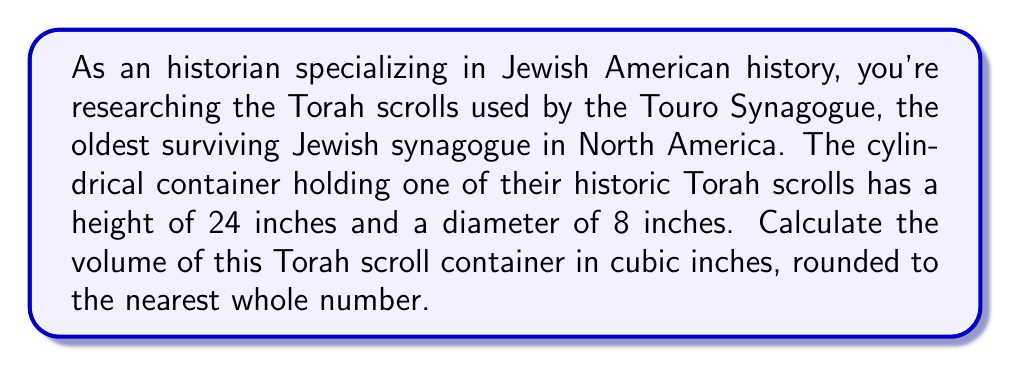Can you answer this question? To solve this problem, we need to use the formula for the volume of a cylinder:

$$V = \pi r^2 h$$

Where:
$V$ = volume
$\pi$ = pi (approximately 3.14159)
$r$ = radius of the base
$h$ = height of the cylinder

Given:
- Height (h) = 24 inches
- Diameter = 8 inches

Step 1: Calculate the radius
The radius is half the diameter:
$r = 8 \div 2 = 4$ inches

Step 2: Apply the volume formula
$$V = \pi (4\text{ in})^2 (24\text{ in})$$

Step 3: Simplify
$$V = \pi (16\text{ in}^2) (24\text{ in})$$
$$V = 384\pi\text{ in}^3$$

Step 4: Calculate and round to the nearest whole number
$$V \approx 384 \times 3.14159 \approx 1206.37\text{ in}^3$$

Rounded to the nearest whole number: 1206 cubic inches

[asy]
import three;

size(200);
currentprojection=perspective(6,3,2);

triple cyl_center = (0,0,12);
path3 p = circle((0,0,0),4);

draw(surface(p -- shift(0,0,24)*p -- cycle), paleblue+opacity(.5));
draw(p,blue);
draw(shift(0,0,24)*p,blue);

draw((4,0,0)--(4,0,24),blue+dashed);
draw((0,4,0)--(0,4,24),blue+dashed);
draw((-4,0,0)--(-4,0,24),blue+dashed);
draw((0,-4,0)--(0,-4,24),blue+dashed);

label("24 in", (5,0,12), E);
label("8 in", (0,0,-1), S);

dot(cyl_center,red);
[/asy]
Answer: The volume of the cylindrical Torah scroll container is approximately 1206 cubic inches. 